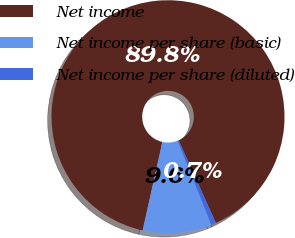Convert chart. <chart><loc_0><loc_0><loc_500><loc_500><pie_chart><fcel>Net income<fcel>Net income per share (basic)<fcel>Net income per share (diluted)<nl><fcel>89.77%<fcel>9.57%<fcel>0.66%<nl></chart> 